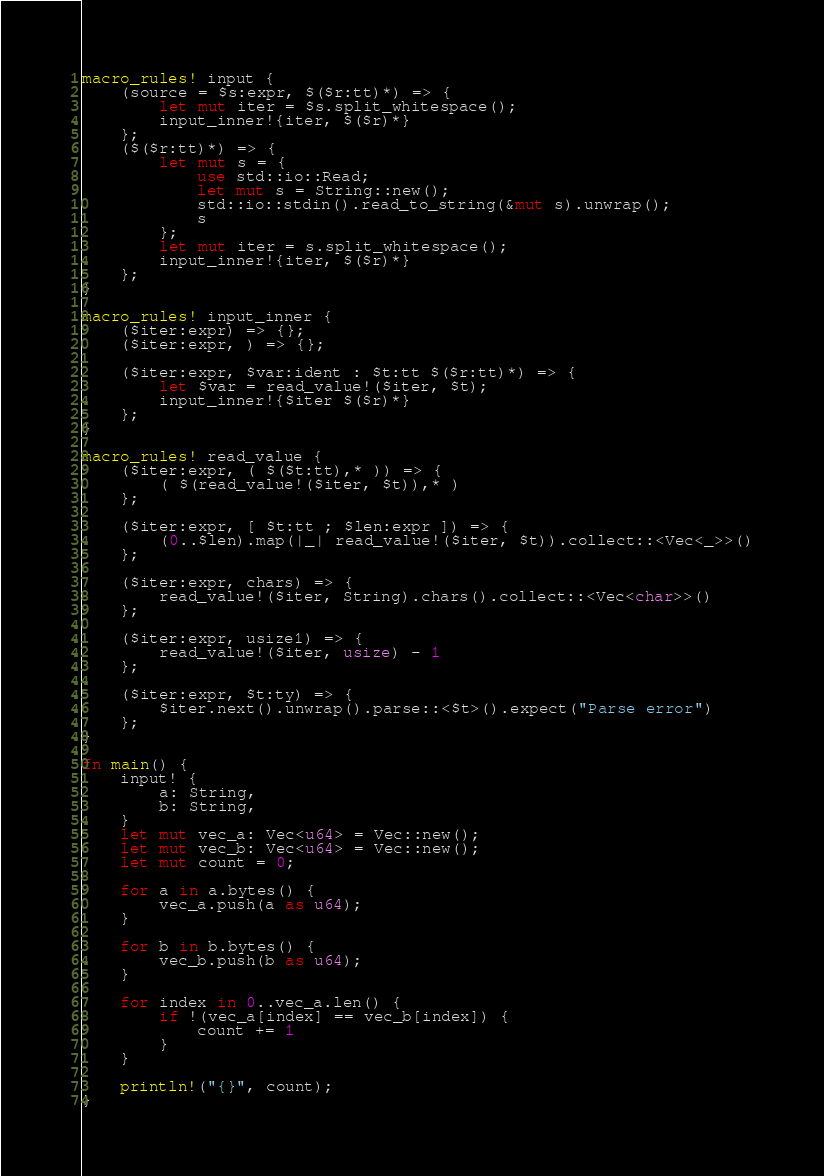<code> <loc_0><loc_0><loc_500><loc_500><_Rust_>macro_rules! input {
    (source = $s:expr, $($r:tt)*) => {
        let mut iter = $s.split_whitespace();
        input_inner!{iter, $($r)*}
    };
    ($($r:tt)*) => {
        let mut s = {
            use std::io::Read;
            let mut s = String::new();
            std::io::stdin().read_to_string(&mut s).unwrap();
            s
        };
        let mut iter = s.split_whitespace();
        input_inner!{iter, $($r)*}
    };
}

macro_rules! input_inner {
    ($iter:expr) => {};
    ($iter:expr, ) => {};

    ($iter:expr, $var:ident : $t:tt $($r:tt)*) => {
        let $var = read_value!($iter, $t);
        input_inner!{$iter $($r)*}
    };
}

macro_rules! read_value {
    ($iter:expr, ( $($t:tt),* )) => {
        ( $(read_value!($iter, $t)),* )
    };

    ($iter:expr, [ $t:tt ; $len:expr ]) => {
        (0..$len).map(|_| read_value!($iter, $t)).collect::<Vec<_>>()
    };

    ($iter:expr, chars) => {
        read_value!($iter, String).chars().collect::<Vec<char>>()
    };

    ($iter:expr, usize1) => {
        read_value!($iter, usize) - 1
    };

    ($iter:expr, $t:ty) => {
        $iter.next().unwrap().parse::<$t>().expect("Parse error")
    };
}

fn main() {
    input! {
        a: String,
        b: String,
    }
    let mut vec_a: Vec<u64> = Vec::new();
    let mut vec_b: Vec<u64> = Vec::new();
    let mut count = 0;

    for a in a.bytes() {
        vec_a.push(a as u64);
    }

    for b in b.bytes() {
        vec_b.push(b as u64);
    }

    for index in 0..vec_a.len() {
        if !(vec_a[index] == vec_b[index]) {
            count += 1
        }
    }

    println!("{}", count);
}
</code> 